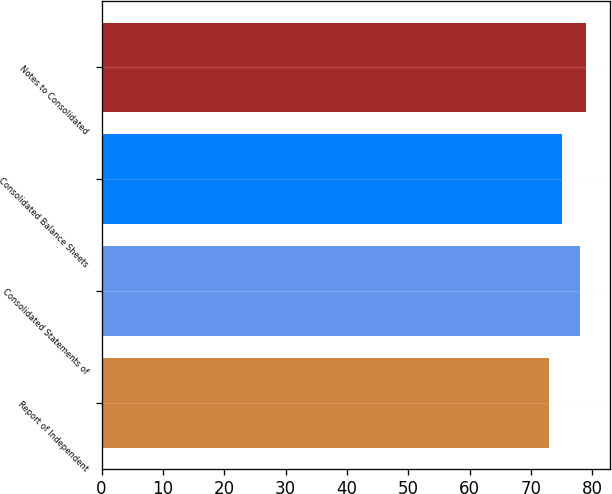Convert chart to OTSL. <chart><loc_0><loc_0><loc_500><loc_500><bar_chart><fcel>Report of Independent<fcel>Consolidated Statements of<fcel>Consolidated Balance Sheets<fcel>Notes to Consolidated<nl><fcel>73<fcel>78<fcel>75<fcel>79<nl></chart> 